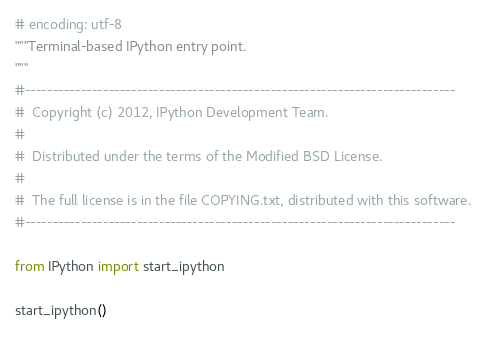<code> <loc_0><loc_0><loc_500><loc_500><_Python_># encoding: utf-8
"""Terminal-based IPython entry point.
"""
#-----------------------------------------------------------------------------
#  Copyright (c) 2012, IPython Development Team.
#
#  Distributed under the terms of the Modified BSD License.
#
#  The full license is in the file COPYING.txt, distributed with this software.
#-----------------------------------------------------------------------------

from IPython import start_ipython

start_ipython()
</code> 